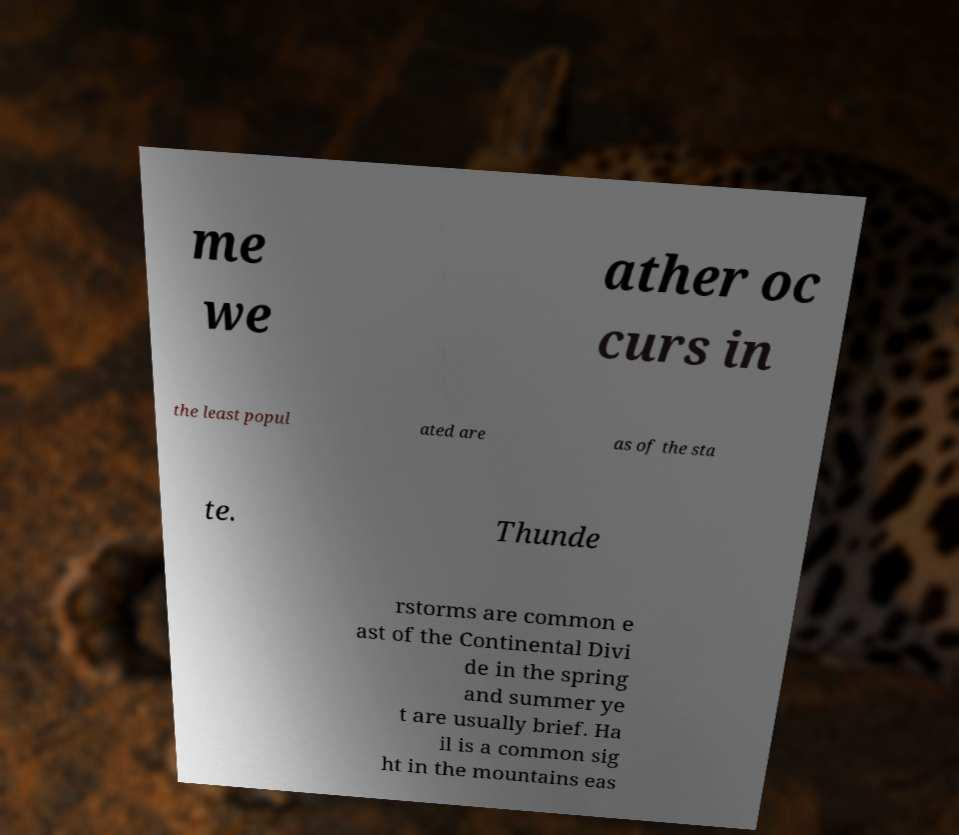Please read and relay the text visible in this image. What does it say? me we ather oc curs in the least popul ated are as of the sta te. Thunde rstorms are common e ast of the Continental Divi de in the spring and summer ye t are usually brief. Ha il is a common sig ht in the mountains eas 